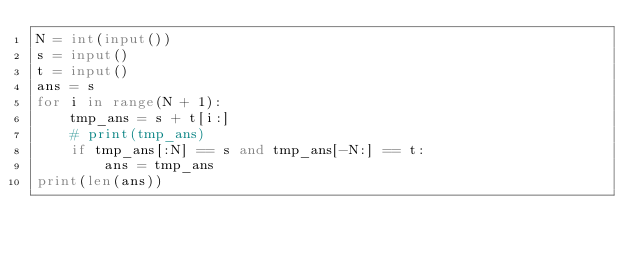<code> <loc_0><loc_0><loc_500><loc_500><_Python_>N = int(input())
s = input()
t = input()
ans = s
for i in range(N + 1):
    tmp_ans = s + t[i:]
    # print(tmp_ans)
    if tmp_ans[:N] == s and tmp_ans[-N:] == t:
        ans = tmp_ans
print(len(ans))
</code> 